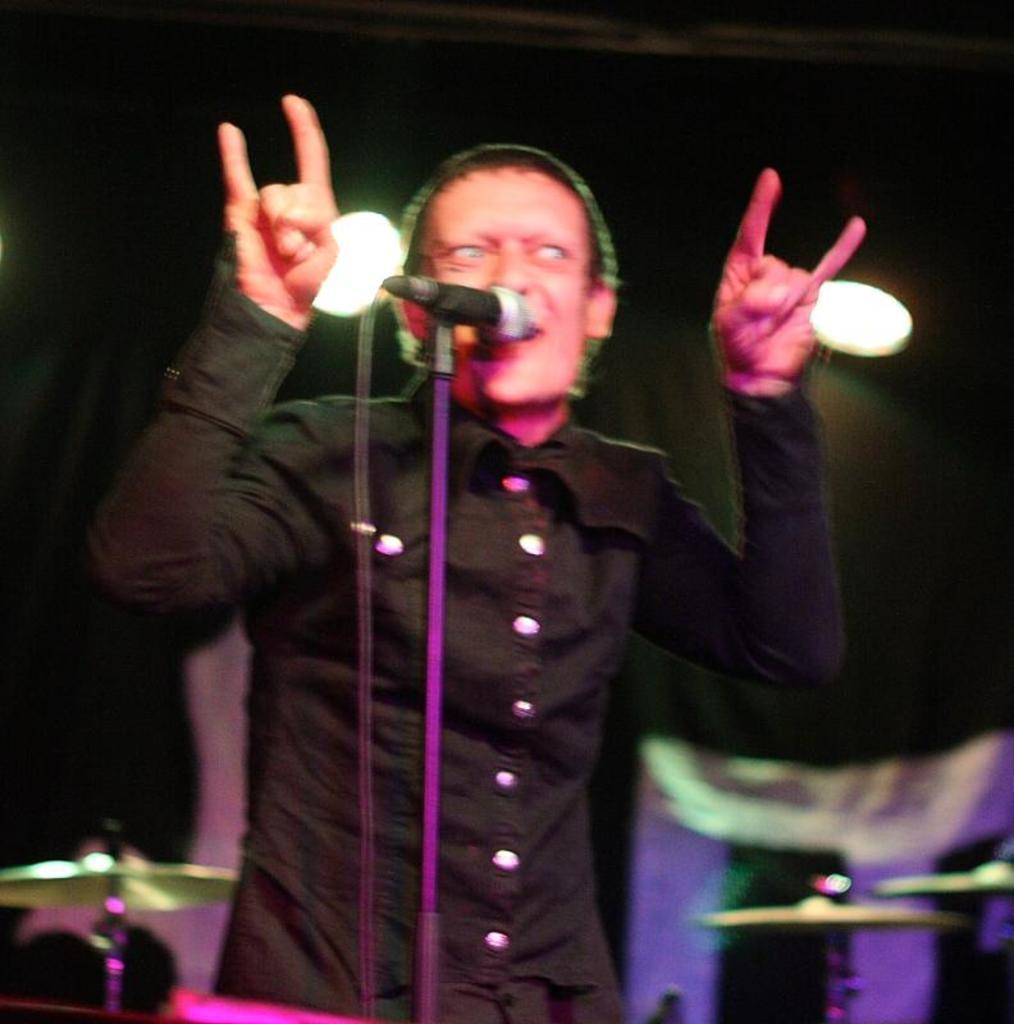Please provide a concise description of this image. This image consists of a person who is wearing black dress. Mike is in front of him. There are lights on the top. There are some musical instruments in the bottom. They are behind him. 